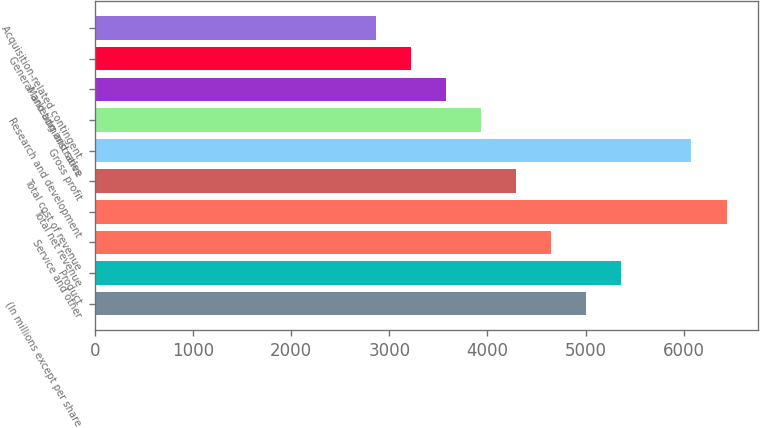<chart> <loc_0><loc_0><loc_500><loc_500><bar_chart><fcel>(In millions except per share<fcel>Product<fcel>Service and other<fcel>Total net revenue<fcel>Total cost of revenue<fcel>Gross profit<fcel>Research and development<fcel>Marketing and sales<fcel>General and administrative<fcel>Acquisition-related contingent<nl><fcel>5005.03<fcel>5362.53<fcel>4647.53<fcel>6435.03<fcel>4290.03<fcel>6077.53<fcel>3932.53<fcel>3575.03<fcel>3217.53<fcel>2860.03<nl></chart> 